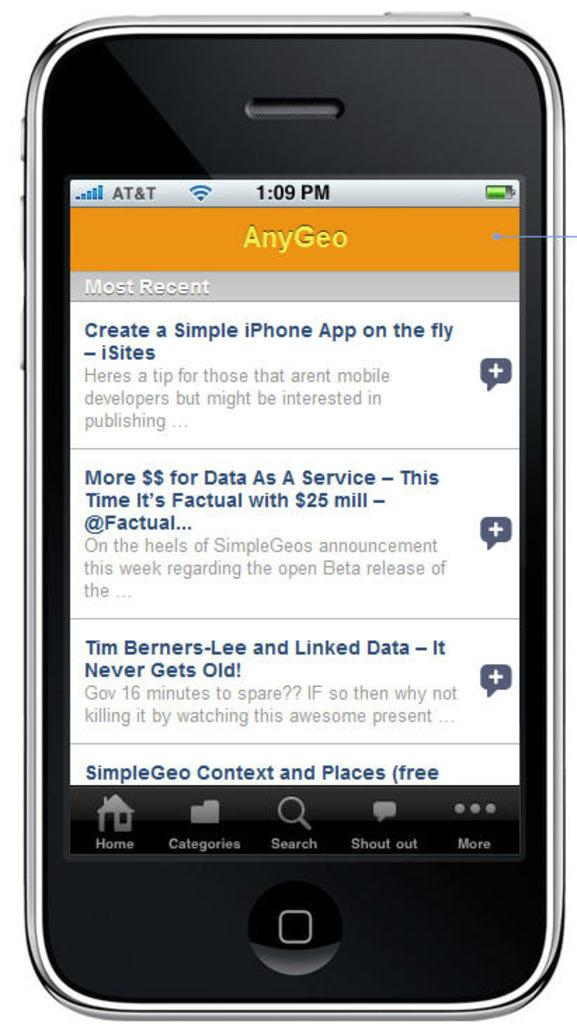<image>
Provide a brief description of the given image. A phone shows AnyGeo app with details on how to create a simple iphone app on the fly 